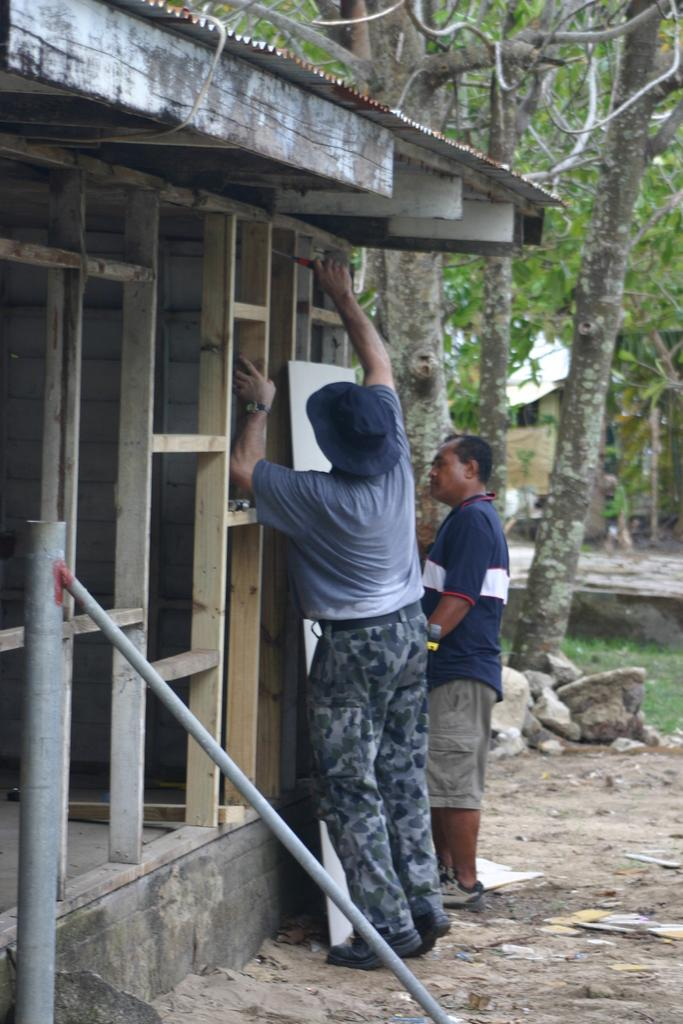How many people are in the image? There are two men standing in the image. What can be seen on the left side of the image? There is a tin roof shed on the left side of the image. What type of natural scenery is visible in the background of the image? There are trees visible in the background of the image. What type of humor can be seen in the image? There is no humor present in the image; it is a simple scene of two men standing near a tin roof shed. 